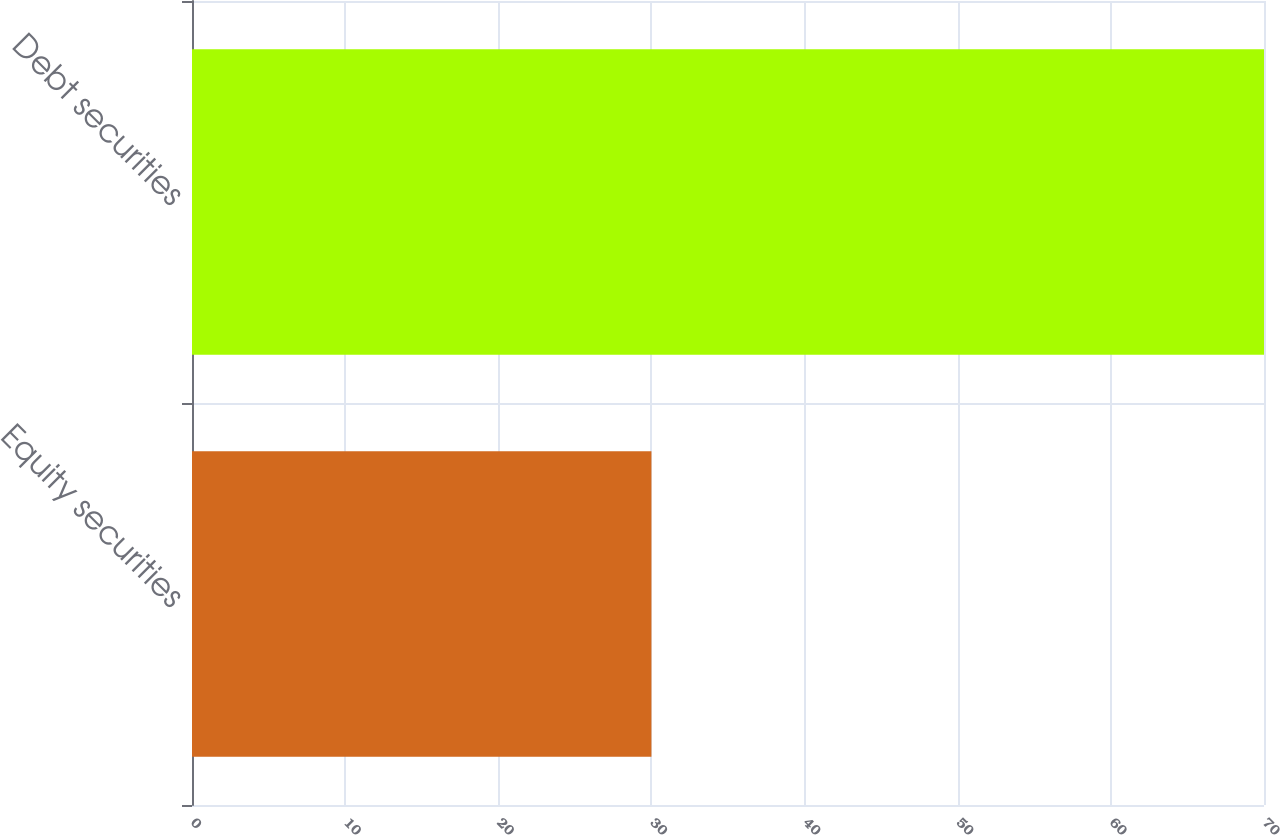Convert chart to OTSL. <chart><loc_0><loc_0><loc_500><loc_500><bar_chart><fcel>Equity securities<fcel>Debt securities<nl><fcel>30<fcel>70<nl></chart> 